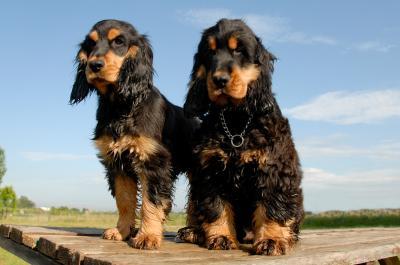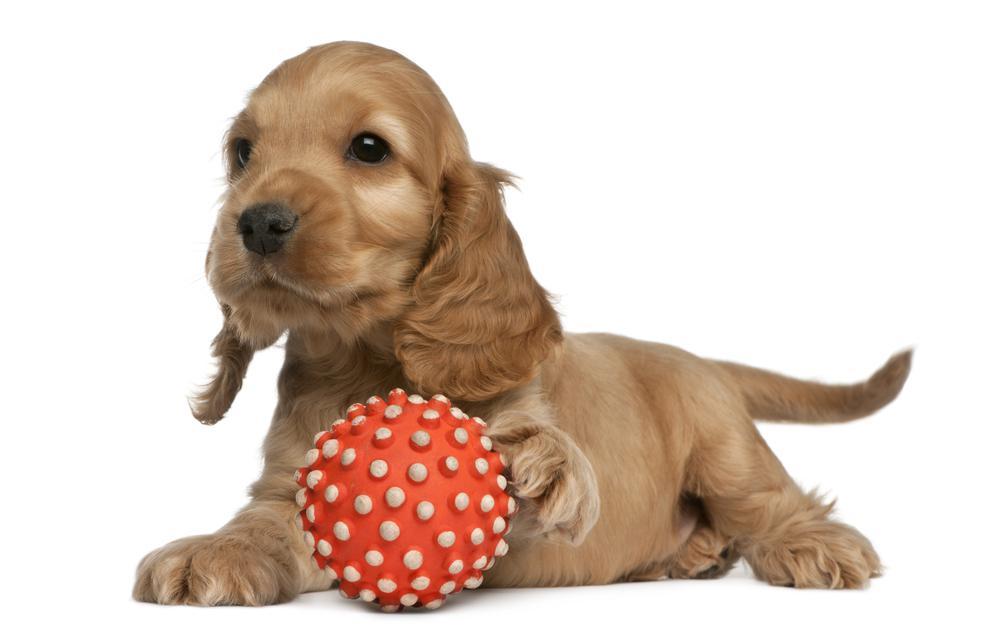The first image is the image on the left, the second image is the image on the right. Analyze the images presented: Is the assertion "An image shows one reclining dog with a paw on an object." valid? Answer yes or no. Yes. 